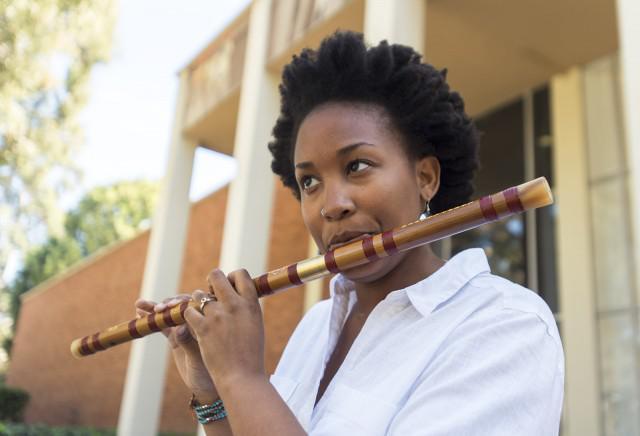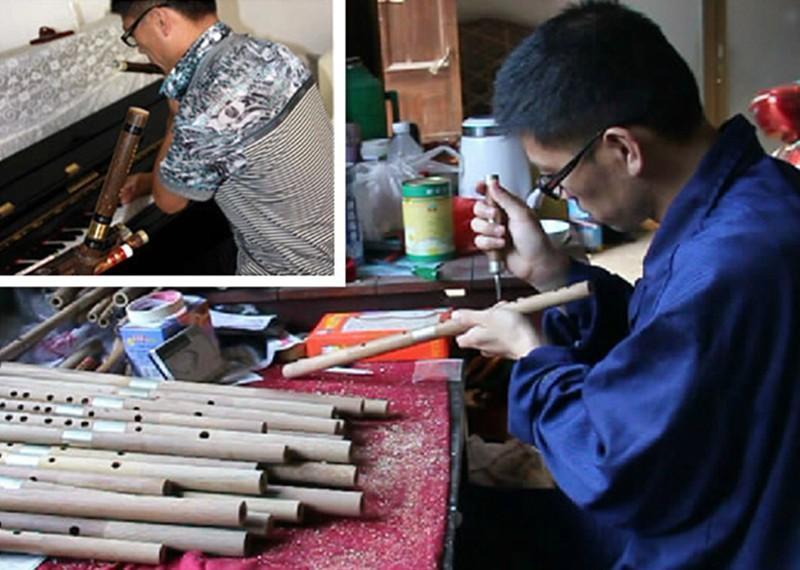The first image is the image on the left, the second image is the image on the right. Given the left and right images, does the statement "There are exactly five flutes." hold true? Answer yes or no. No. 